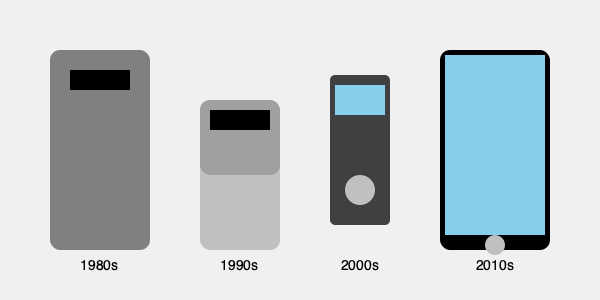As a tech-savvy food blogger who has witnessed the evolution of mobile technology, which era of mobile phones do you think had the most significant impact on the way people shared food experiences online, and why? To answer this question, let's consider the evolution of mobile phones and their impact on food blogging:

1. 1980s (Brick Phone):
   - Limited to voice calls
   - No internet connectivity or camera
   - Impact on food blogging: Minimal to none

2. 1990s (Flip Phone):
   - Introduced SMS texting
   - Some models had basic cameras
   - Impact on food blogging: Limited; could share basic text descriptions

3. 2000s (Candy Bar Phone):
   - Improved cameras
   - Basic internet connectivity
   - Impact on food blogging: Moderate; could share low-quality food photos and short reviews

4. 2010s (Smartphone):
   - High-quality cameras
   - Fast internet connectivity
   - Social media integration
   - GPS for location tagging
   - Apps for editing and sharing content
   - Impact on food blogging: Significant; enabled real-time sharing of high-quality food photos, detailed reviews, and location information

The 2010s smartphone era had the most significant impact on food blogging because:
- It allowed for instant sharing of high-quality food photos
- Social media integration made it easy to reach a wide audience
- Location tagging helped promote local restaurants
- Food-specific apps emerged for reviews and recommendations
- The ability to edit photos and write longer posts on-the-go improved content quality

This era democratized food blogging, making it accessible to anyone with a smartphone, and dramatically changed how people discovered and shared food experiences.
Answer: 2010s (Smartphone era) 